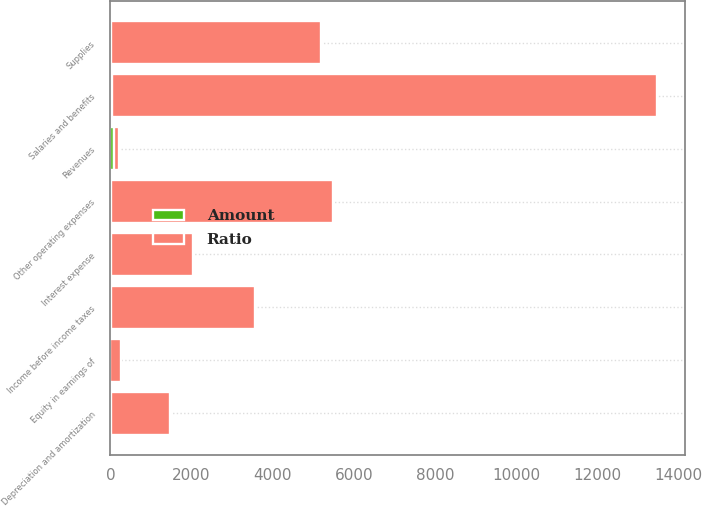<chart> <loc_0><loc_0><loc_500><loc_500><stacked_bar_chart><ecel><fcel>Revenues<fcel>Salaries and benefits<fcel>Supplies<fcel>Other operating expenses<fcel>Equity in earnings of<fcel>Depreciation and amortization<fcel>Interest expense<fcel>Income before income taxes<nl><fcel>Ratio<fcel>100<fcel>13440<fcel>5179<fcel>5470<fcel>258<fcel>1465<fcel>2037<fcel>3561<nl><fcel>Amount<fcel>100<fcel>45.3<fcel>17.4<fcel>18.5<fcel>0.9<fcel>4.9<fcel>6.9<fcel>12<nl></chart> 